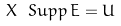Convert formula to latex. <formula><loc_0><loc_0><loc_500><loc_500>X \ S u p p \, E = U</formula> 